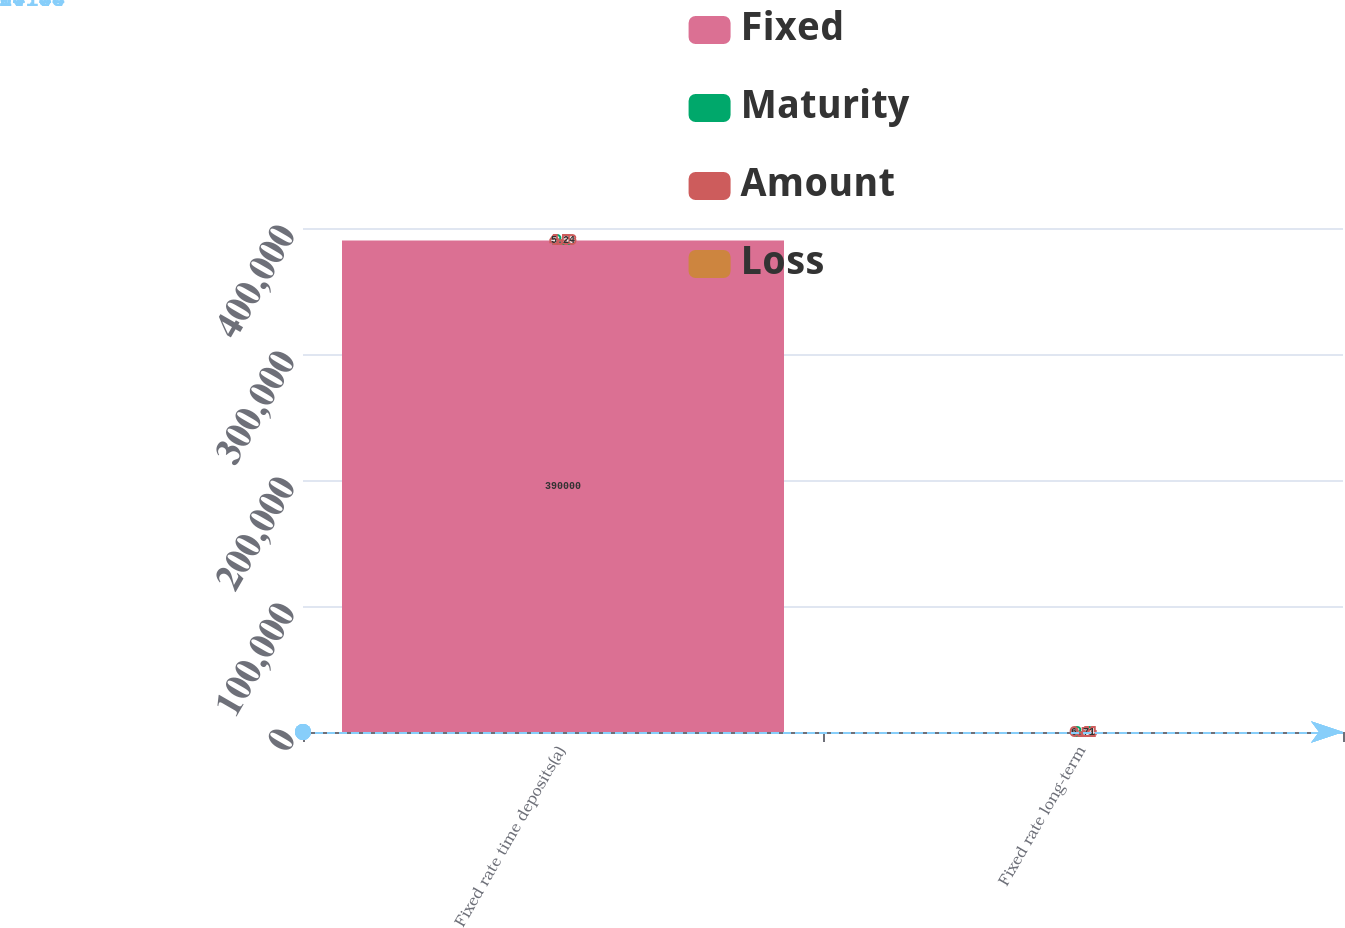Convert chart. <chart><loc_0><loc_0><loc_500><loc_500><stacked_bar_chart><ecel><fcel>Fixed rate time deposits(a)<fcel>Fixed rate long-term<nl><fcel>Fixed<fcel>390000<fcel>6.14<nl><fcel>Maturity<fcel>2.9<fcel>8.6<nl><fcel>Amount<fcel>4.58<fcel>6.14<nl><fcel>Loss<fcel>5.24<fcel>6.71<nl></chart> 